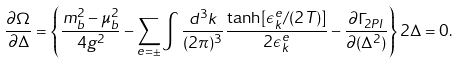Convert formula to latex. <formula><loc_0><loc_0><loc_500><loc_500>\frac { \partial \Omega } { \partial \Delta } = \left \{ \frac { m _ { b } ^ { 2 } - \mu _ { b } ^ { 2 } } { 4 g ^ { 2 } } - \sum _ { e = \pm } \int \frac { d ^ { 3 } k } { ( 2 \pi ) ^ { 3 } } \frac { \tanh [ \epsilon _ { k } ^ { e } / ( 2 T ) ] } { 2 \epsilon _ { k } ^ { e } } - \frac { \partial \Gamma _ { 2 P I } } { \partial ( \Delta ^ { 2 } ) } \right \} 2 \Delta = 0 .</formula> 